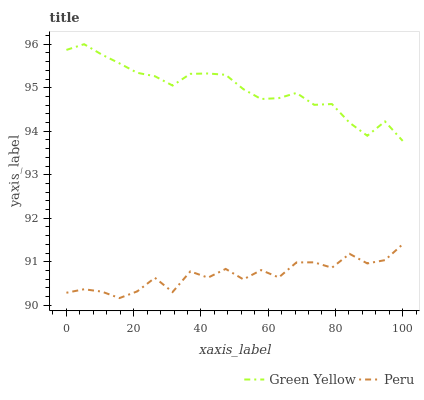Does Peru have the minimum area under the curve?
Answer yes or no. Yes. Does Green Yellow have the maximum area under the curve?
Answer yes or no. Yes. Does Peru have the maximum area under the curve?
Answer yes or no. No. Is Green Yellow the smoothest?
Answer yes or no. Yes. Is Peru the roughest?
Answer yes or no. Yes. Is Peru the smoothest?
Answer yes or no. No. Does Peru have the lowest value?
Answer yes or no. Yes. Does Green Yellow have the highest value?
Answer yes or no. Yes. Does Peru have the highest value?
Answer yes or no. No. Is Peru less than Green Yellow?
Answer yes or no. Yes. Is Green Yellow greater than Peru?
Answer yes or no. Yes. Does Peru intersect Green Yellow?
Answer yes or no. No. 